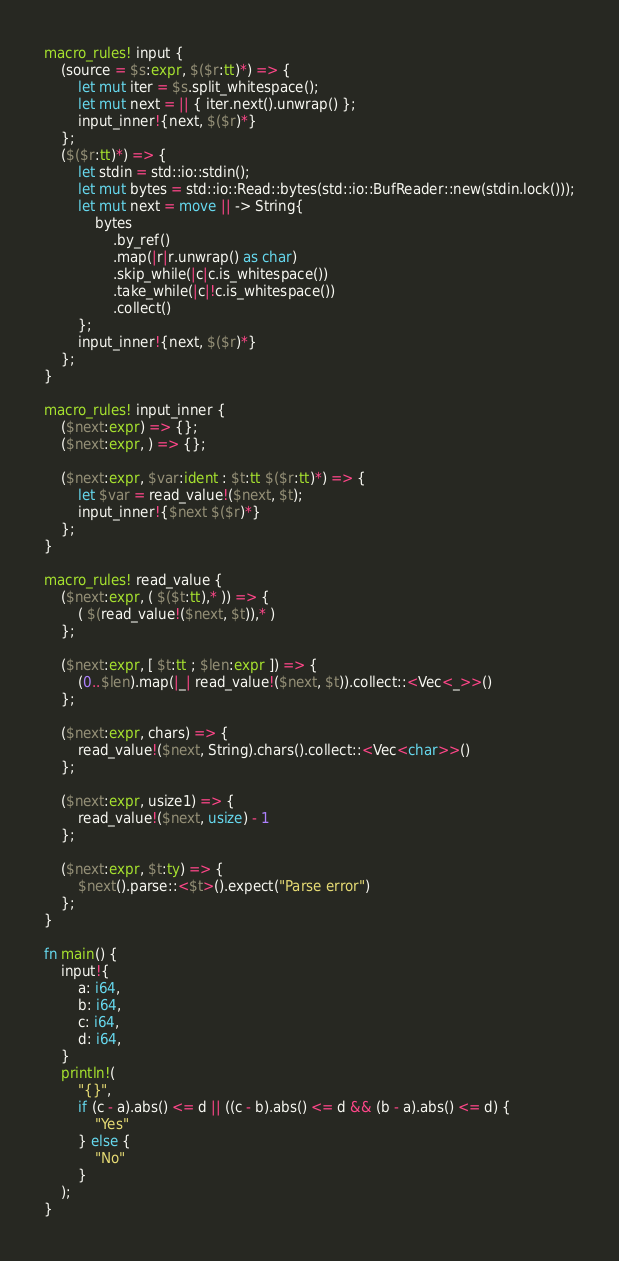<code> <loc_0><loc_0><loc_500><loc_500><_Rust_>macro_rules! input {
    (source = $s:expr, $($r:tt)*) => {
        let mut iter = $s.split_whitespace();
        let mut next = || { iter.next().unwrap() };
        input_inner!{next, $($r)*}
    };
    ($($r:tt)*) => {
        let stdin = std::io::stdin();
        let mut bytes = std::io::Read::bytes(std::io::BufReader::new(stdin.lock()));
        let mut next = move || -> String{
            bytes
                .by_ref()
                .map(|r|r.unwrap() as char)
                .skip_while(|c|c.is_whitespace())
                .take_while(|c|!c.is_whitespace())
                .collect()
        };
        input_inner!{next, $($r)*}
    };
}

macro_rules! input_inner {
    ($next:expr) => {};
    ($next:expr, ) => {};

    ($next:expr, $var:ident : $t:tt $($r:tt)*) => {
        let $var = read_value!($next, $t);
        input_inner!{$next $($r)*}
    };
}

macro_rules! read_value {
    ($next:expr, ( $($t:tt),* )) => {
        ( $(read_value!($next, $t)),* )
    };

    ($next:expr, [ $t:tt ; $len:expr ]) => {
        (0..$len).map(|_| read_value!($next, $t)).collect::<Vec<_>>()
    };

    ($next:expr, chars) => {
        read_value!($next, String).chars().collect::<Vec<char>>()
    };

    ($next:expr, usize1) => {
        read_value!($next, usize) - 1
    };

    ($next:expr, $t:ty) => {
        $next().parse::<$t>().expect("Parse error")
    };
}

fn main() {
    input!{
        a: i64,
        b: i64,
        c: i64,
        d: i64,
    }
    println!(
        "{}",
        if (c - a).abs() <= d || ((c - b).abs() <= d && (b - a).abs() <= d) {
            "Yes"
        } else {
            "No"
        }
    );
}
</code> 